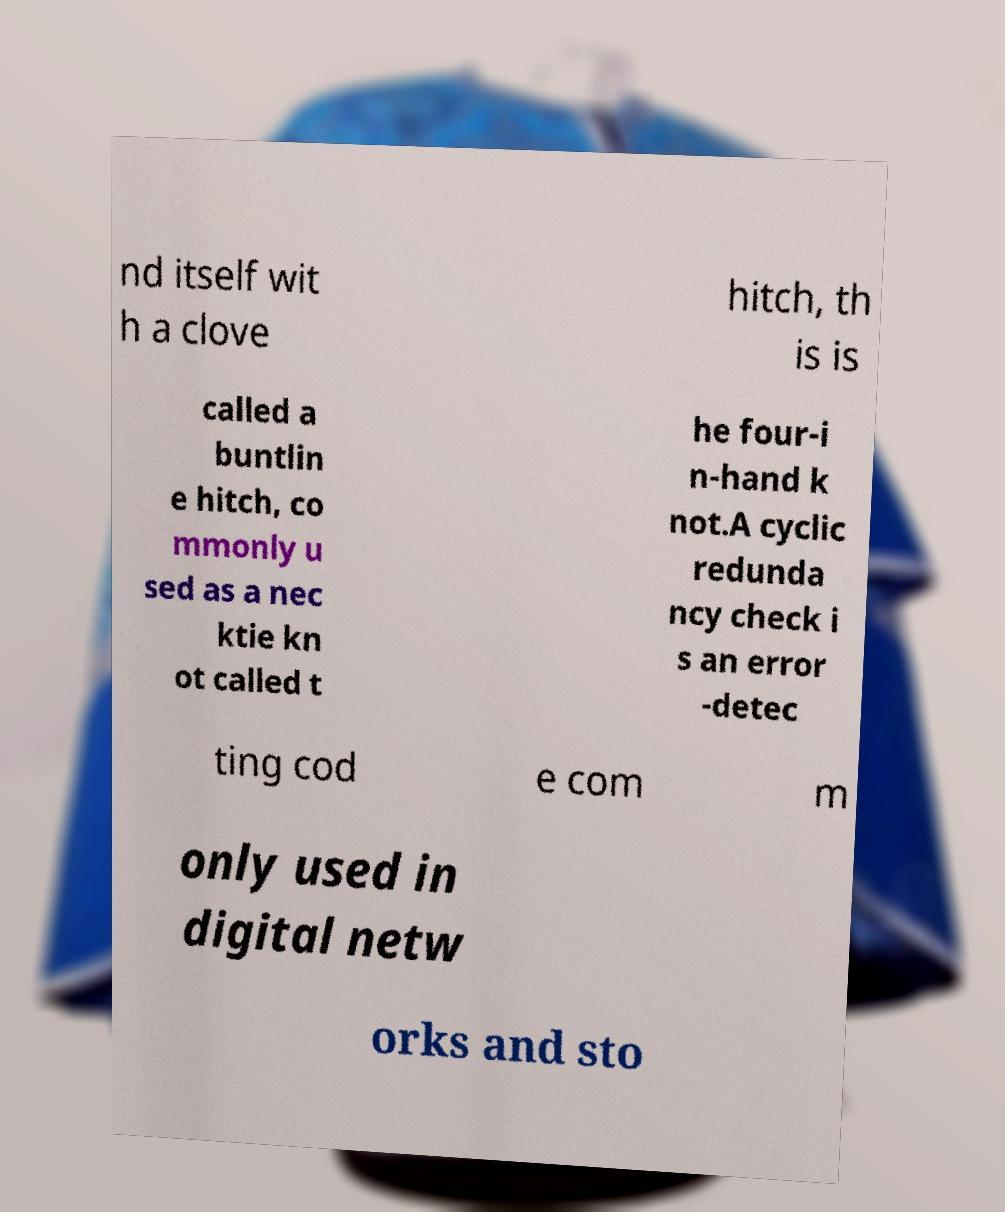For documentation purposes, I need the text within this image transcribed. Could you provide that? nd itself wit h a clove hitch, th is is called a buntlin e hitch, co mmonly u sed as a nec ktie kn ot called t he four-i n-hand k not.A cyclic redunda ncy check i s an error -detec ting cod e com m only used in digital netw orks and sto 